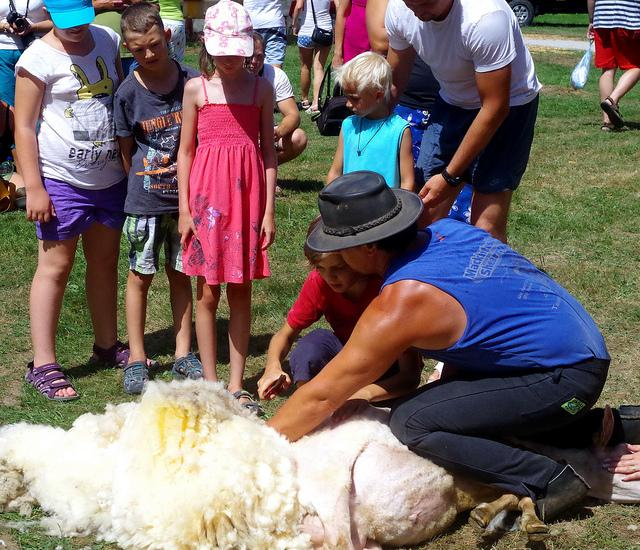Why is the animal on the ground? shearing 